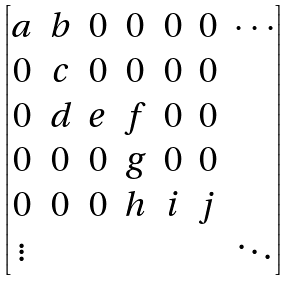<formula> <loc_0><loc_0><loc_500><loc_500>\begin{bmatrix} a & b & 0 & 0 & 0 & 0 & \cdots \\ 0 & c & 0 & 0 & 0 & 0 & \\ 0 & d & e & f & 0 & 0 & \\ 0 & 0 & 0 & g & 0 & 0 & \\ 0 & 0 & 0 & h & i & j & \\ \vdots & & & & & & \ddots \end{bmatrix}</formula> 